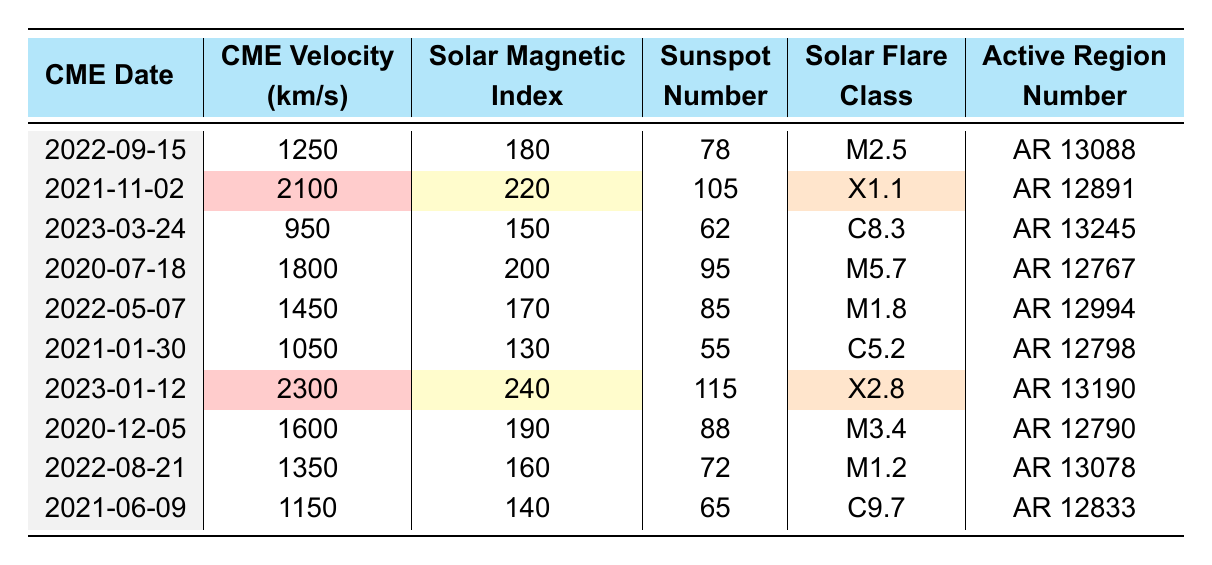What is the CME velocity recorded on 2021-11-02? Referring to the table, the CME velocity on this date is clearly listed as 2100 km/s.
Answer: 2100 km/s Which solar flare class corresponds to the CME with the highest velocity? Looking at the table, the highest CME velocity is 2300 km/s, which occurs on 2023-01-12, with a corresponding solar flare class of X2.8.
Answer: X2.8 What is the solar magnetic index on the date with the lowest CME velocity? The lowest CME velocity recorded in the table is 950 km/s on 2023-03-24, with a solar magnetic index of 150.
Answer: 150 What is the average CME velocity for the entries listed? To find the average, add all the CME velocities: (1250 + 2100 + 950 + 1800 + 1450 + 1050 + 2300 + 1600 + 1350 + 1150) = 15,900 km/s. There are 10 entries, so the average is 15,900 / 10 = 1590 km/s.
Answer: 1590 km/s Were there any recorded CMEs with a solar magnetic index above 200? Checking the table, the dates with a solar magnetic index above 200 are 2021-11-02 and 2023-01-12, which have indexes of 220 and 240, respectively.
Answer: Yes What is the sunspot number associated with the CME that occurred on 2020-07-18? The table indicates that the sunspot number on this date is 95.
Answer: 95 Is there a correlation between the solar magnetic index and CME velocity? By observing the data, it appears that higher CME velocities generally correspond to higher solar magnetic indexes, such as the 2300 km/s on 2023-01-12 with a solar index of 240. However, further statistical analysis would be needed for definitive confirmation.
Answer: Generally yes, but further analysis needed What was the flare class for the CME associated with active region AR 13088? From the table, the CME associated with AR 13088 on 2022-09-15 is classified as M2.5.
Answer: M2.5 What is the difference in CME velocities between the highest and lowest recorded? The highest recorded velocity is 2300 km/s and the lowest is 950 km/s. The difference is 2300 - 950 = 1350 km/s.
Answer: 1350 km/s Which date had a CME velocity of 1600 km/s and what was its solar flare class? The date with a CME velocity of 1600 km/s is 2020-12-05, and its solar flare class is M3.4.
Answer: 2020-12-05, M3.4 